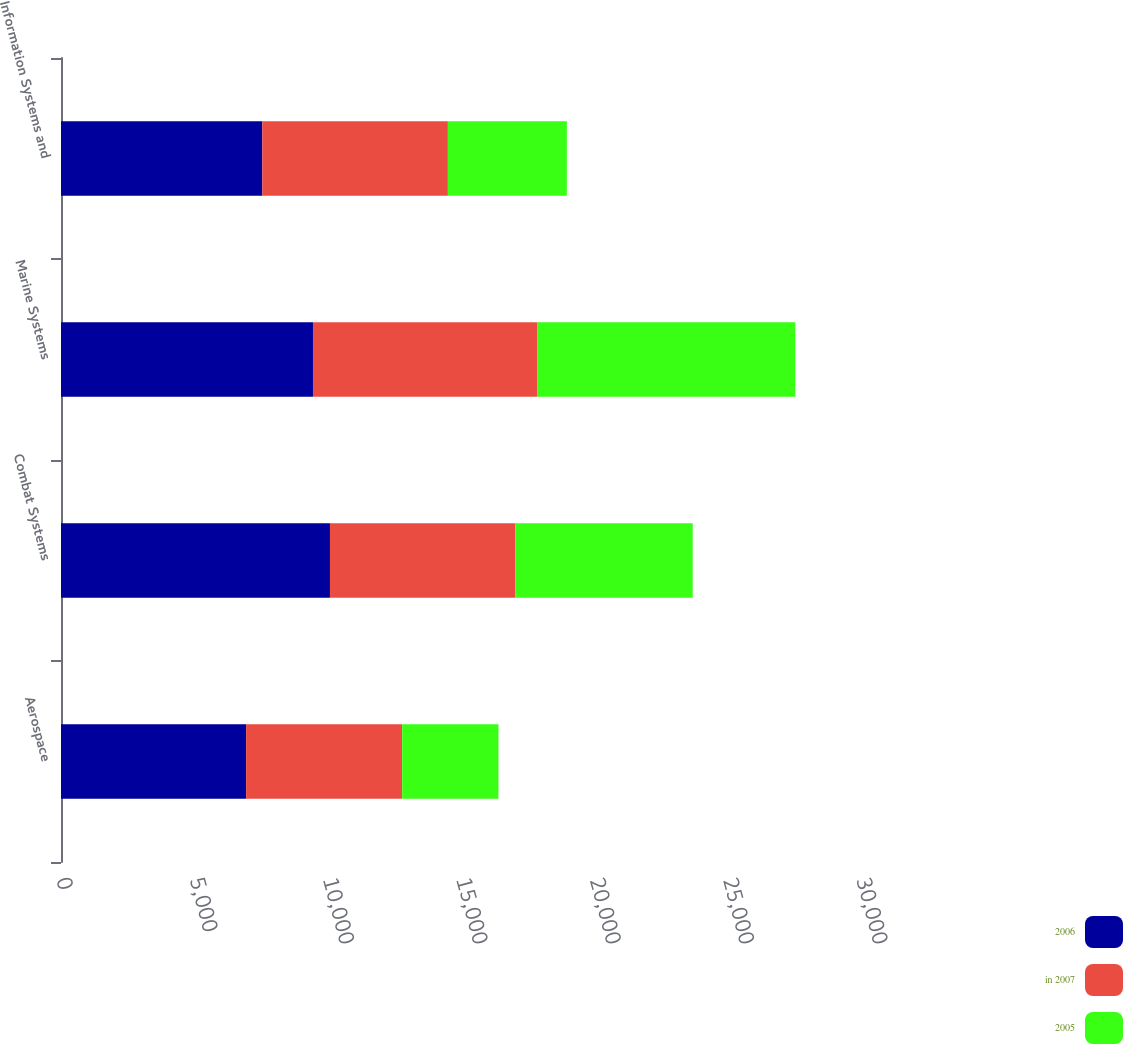Convert chart. <chart><loc_0><loc_0><loc_500><loc_500><stacked_bar_chart><ecel><fcel>Aerospace<fcel>Combat Systems<fcel>Marine Systems<fcel>Information Systems and<nl><fcel>2006<fcel>6941<fcel>10086<fcel>9449<fcel>7548<nl><fcel>in 2007<fcel>5853<fcel>6954<fcel>8419<fcel>6960<nl><fcel>2005<fcel>3610<fcel>6649<fcel>9670<fcel>4462<nl></chart> 